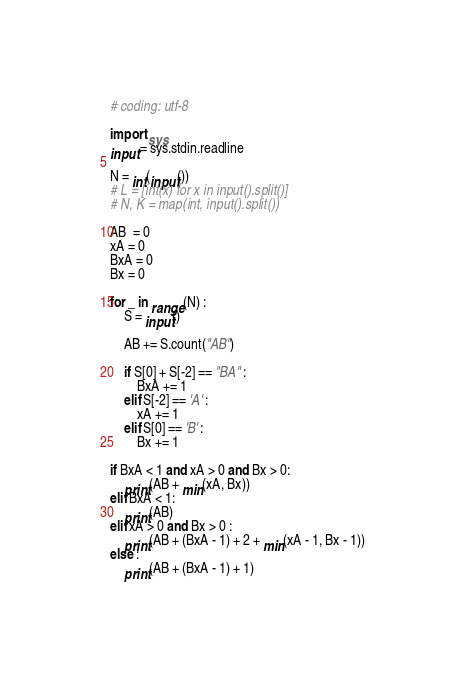<code> <loc_0><loc_0><loc_500><loc_500><_Python_># coding: utf-8

import sys
input = sys.stdin.readline

N = int(input())
# L = [int(x) for x in input().split()]
# N, K = map(int, input().split())

AB  = 0
xA = 0
BxA = 0
Bx = 0

for _ in range(N) :
    S = input()

    AB += S.count("AB")

    if S[0] + S[-2] == "BA" :
        BxA += 1
    elif S[-2] == 'A' :
        xA += 1
    elif S[0] == 'B' :
        Bx += 1

if BxA < 1 and xA > 0 and Bx > 0:
    print(AB + min(xA, Bx))
elif BxA < 1:
    print(AB)
elif xA > 0 and Bx > 0 :
    print(AB + (BxA - 1) + 2 + min(xA - 1, Bx - 1))
else :
    print(AB + (BxA - 1) + 1)
</code> 